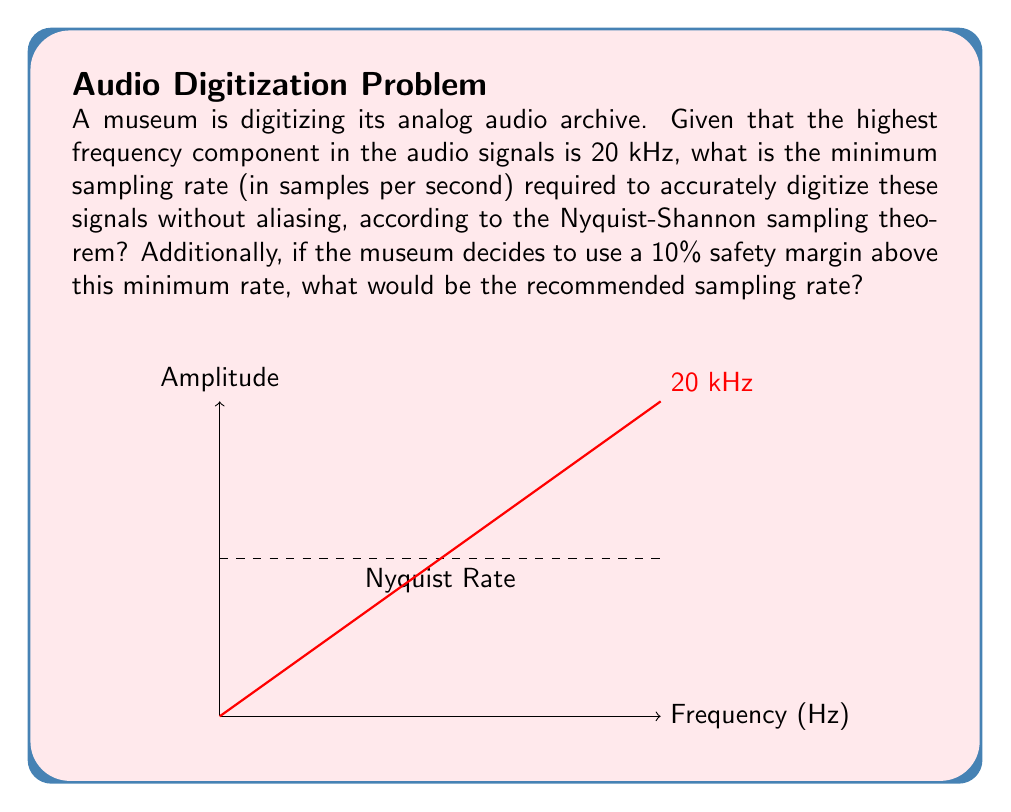Could you help me with this problem? To solve this problem, we'll follow these steps:

1) The Nyquist-Shannon sampling theorem states that to accurately reconstruct a continuous-time signal from its samples, the sampling rate must be at least twice the highest frequency component in the signal.

2) Given:
   - Highest frequency component: $f_{max} = 20$ kHz $= 20,000$ Hz

3) Calculate the minimum sampling rate:
   $f_s \geq 2 \cdot f_{max}$
   $f_s \geq 2 \cdot 20,000$ Hz
   $f_s \geq 40,000$ samples per second

4) To add a 10% safety margin:
   $f_{safety} = f_s \cdot 1.10$
   $f_{safety} = 40,000 \cdot 1.10 = 44,000$ samples per second

Therefore, the minimum sampling rate is 40,000 samples per second, and with a 10% safety margin, the recommended sampling rate is 44,000 samples per second.
Answer: Minimum: 40,000 samples/s; Recommended: 44,000 samples/s 